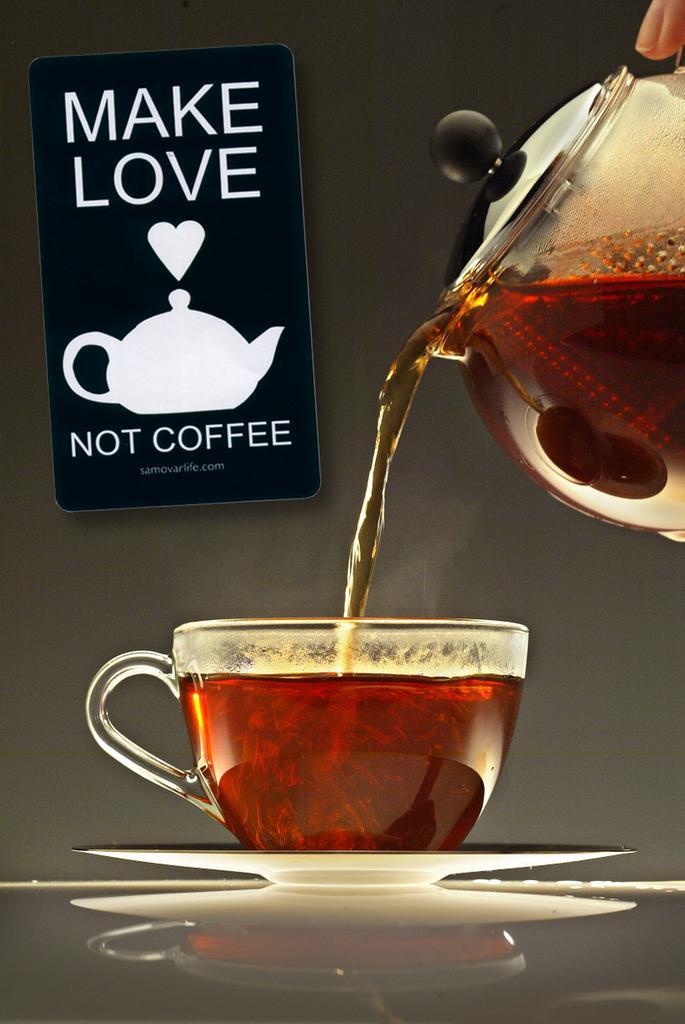Please provide a concise description of this image. In the image in the center, we can see one coffee cup, jar and coffee. In the background there is a wall and a banner. 